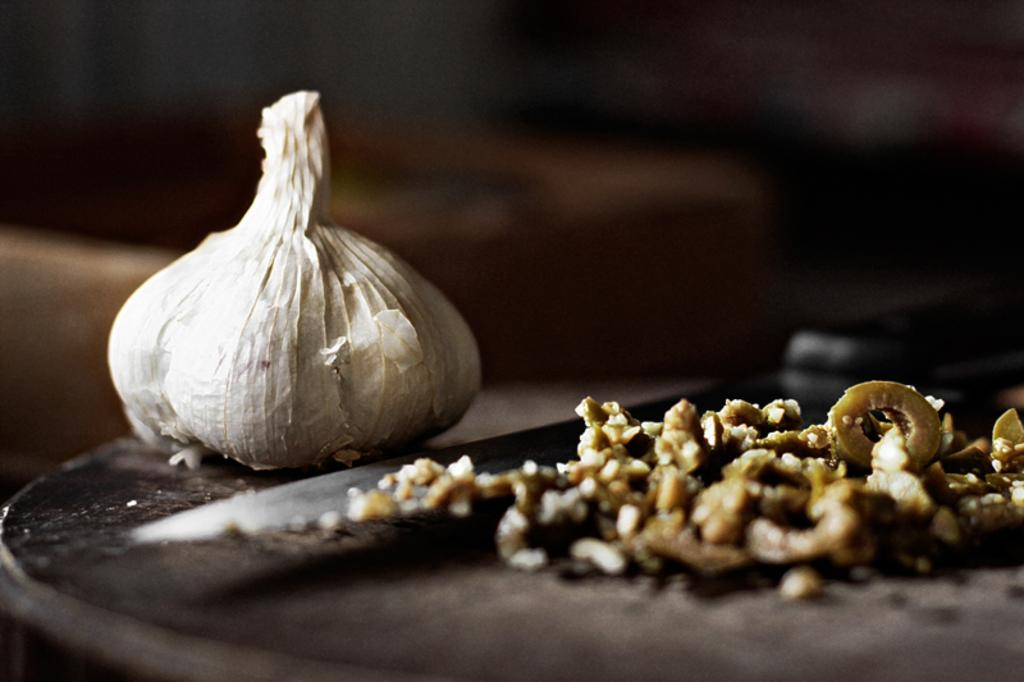What type of food item can be seen in the image? There is a food item in the image, which is garlic. What tool is present in the image? There is a knife in the image. What is the color of the background in the image? The background of the image is dark. What type of help is being offered in the image? There is no indication of help being offered in the image; it only features garlic and a knife. Can you describe the argument taking place in the image? There is no argument present in the image; it only features garlic and a knife. 